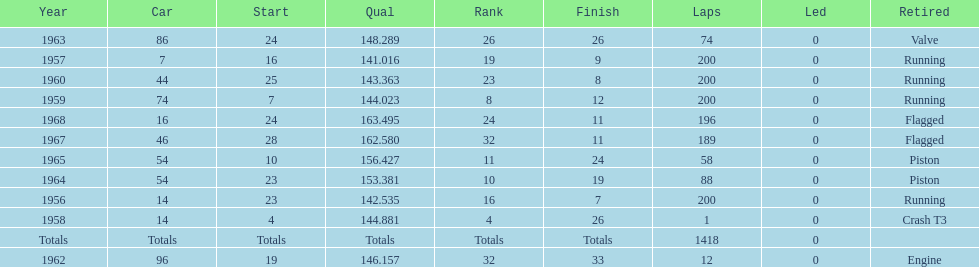Help me parse the entirety of this table. {'header': ['Year', 'Car', 'Start', 'Qual', 'Rank', 'Finish', 'Laps', 'Led', 'Retired'], 'rows': [['1963', '86', '24', '148.289', '26', '26', '74', '0', 'Valve'], ['1957', '7', '16', '141.016', '19', '9', '200', '0', 'Running'], ['1960', '44', '25', '143.363', '23', '8', '200', '0', 'Running'], ['1959', '74', '7', '144.023', '8', '12', '200', '0', 'Running'], ['1968', '16', '24', '163.495', '24', '11', '196', '0', 'Flagged'], ['1967', '46', '28', '162.580', '32', '11', '189', '0', 'Flagged'], ['1965', '54', '10', '156.427', '11', '24', '58', '0', 'Piston'], ['1964', '54', '23', '153.381', '10', '19', '88', '0', 'Piston'], ['1956', '14', '23', '142.535', '16', '7', '200', '0', 'Running'], ['1958', '14', '4', '144.881', '4', '26', '1', '0', 'Crash T3'], ['Totals', 'Totals', 'Totals', 'Totals', 'Totals', 'Totals', '1418', '0', ''], ['1962', '96', '19', '146.157', '32', '33', '12', '0', 'Engine']]} How many times did he finish all 200 laps? 4. 